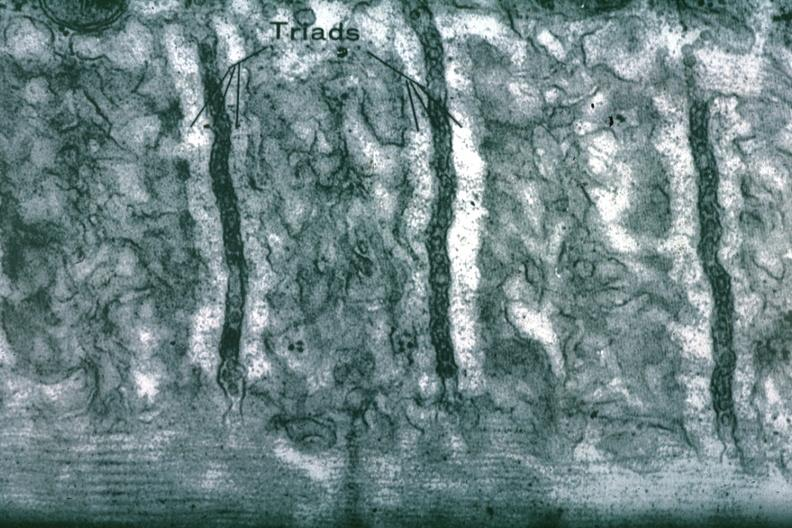s myocardium present?
Answer the question using a single word or phrase. Yes 